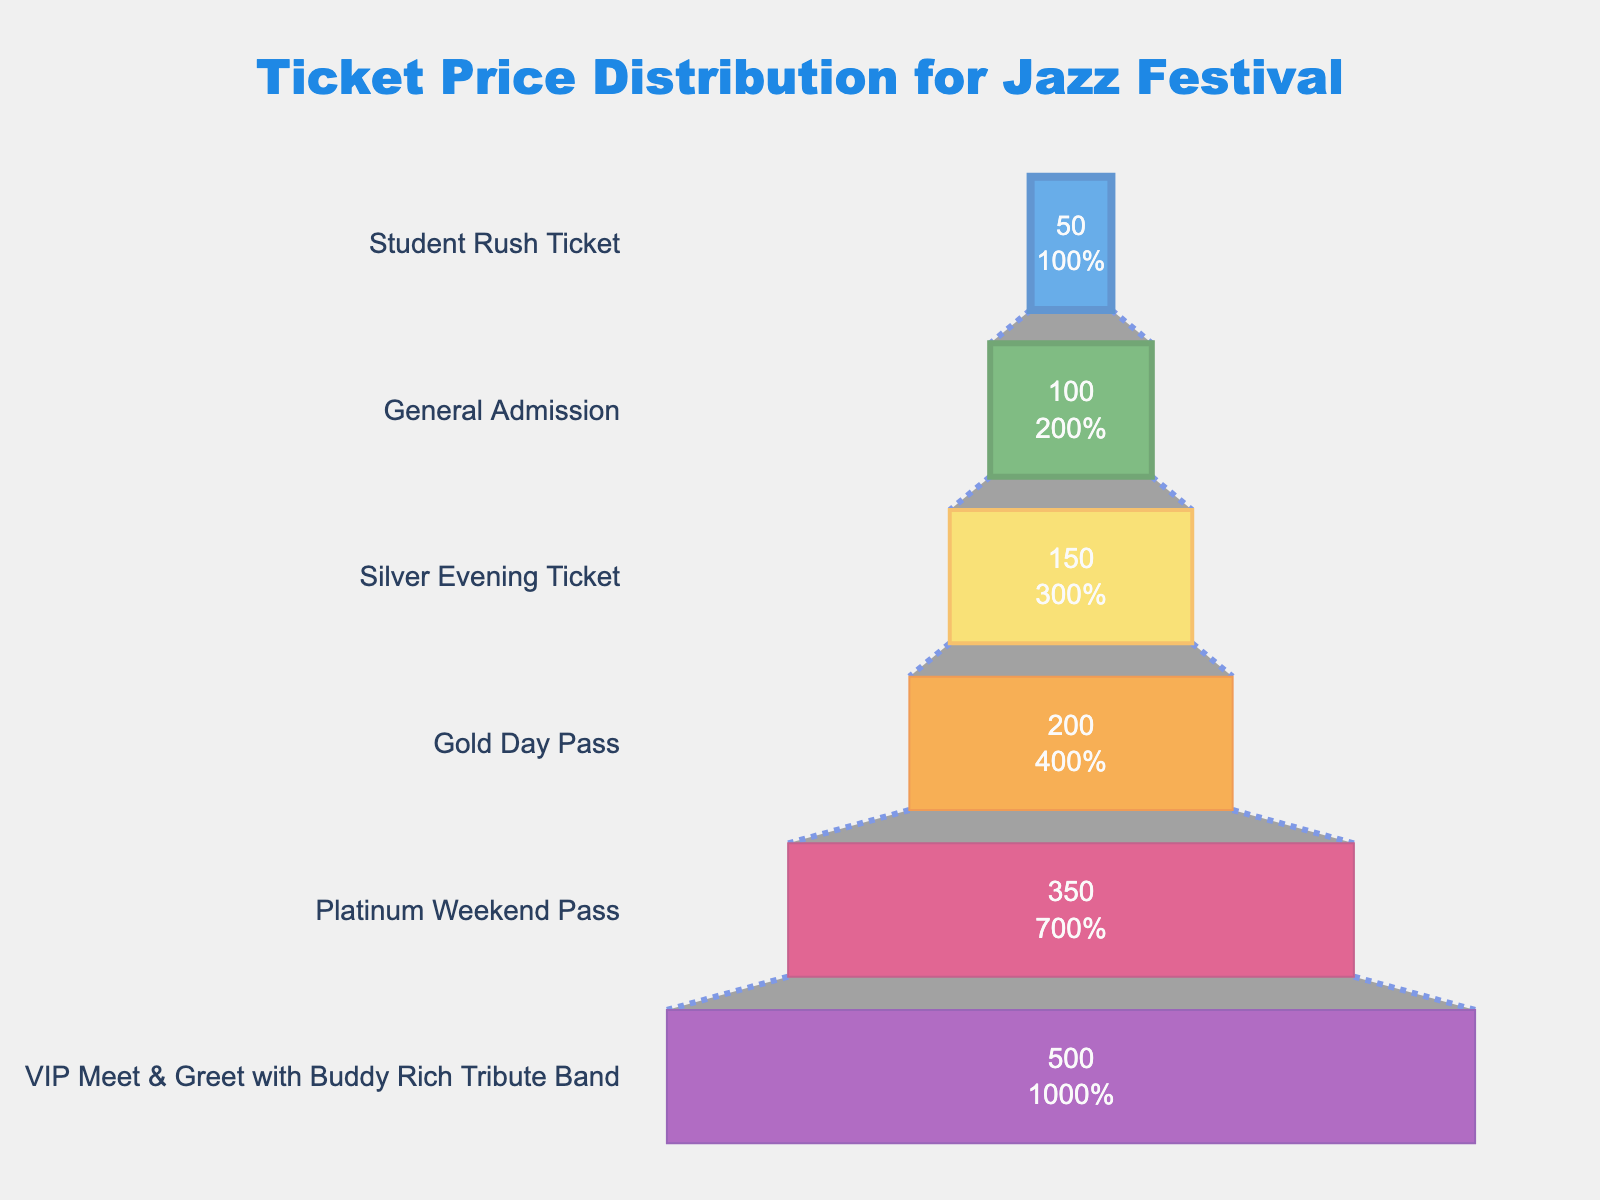what is the title of the chart? The title of the chart is located at the top and is designed to provide a summary of the graph's purpose or content. By reading it, we can determine what data the chart illustrates.
Answer: Ticket Price Distribution for Jazz Festival What is the color of the VIP Meet & Greet with Buddy Rich Tribute Band block? The colors are a visual feature used to differentiate between categories. By looking at the chart's blocks, we can identify the color used for each price tier.
Answer: Blue Which ticket tier has the highest price? To determine the highest price, look for the ticket option positioned at the widest part of the funnel chart, as the sections are ordered from highest price (top) to lowest price (bottom).
Answer: VIP Meet & Greet with Buddy Rich Tribute Band Which ticket categories have a price difference greater than $100 compared to the Student Rush Ticket? Locate the Student Rush Ticket, which is $50, then identify ticket categories with prices exceeding $150, indicating a difference greater than $100.
Answer: VIP Meet & Greet, Platinum Weekend Pass, and Gold Day Pass What percentage of the initial total ticket price does the General Admission ticket represent? Identify the value for General Admission. Calculate the total of all prices and then divide the General Admission price by the total and multiply by 100 to find the percentage. Sum: 1350, Percent: (100 / 1350) * 100.
Answer: 7.41% What's the total of all the ticket prices combined? To get the combined total of all ticket prices, add each price value displayed within the funnel chart.
Answer: 1,350 How many ticket tiers are there in the chart? Count the number of distinct categories or blocks displayed in the funnel chart to determine the number of ticket tiers.
Answer: 6 Which ticket tier’s price is exactly twice the price of the Student Rush Ticket? Identify the Student Rush Ticket price, then find the ticket category that doubles this amount ($50 * 2 = $100).
Answer: General Admission If each ticket type sells an equal number of 10 tickets, what is the total revenue generated from Platinum Weekend Passes and Gold Day Passes combined? Multiply the price of each ticket by 10 to get the individual revenue and then add these revenues together for the Platinum Weekend Pass and Gold Day Pass. ($350*10 + $200*10).
Answer: $5,500 Which two ticket categories have the smallest price difference? Compute the price difference between each adjacent ticket category and identify the pair with the smallest absolute difference. The adjacent price pairs are 100 - 50, 150 - 100, 200 - 150, 350 - 200, and 500 - 350.
Answer: General Admission and Student Rush Ticket 